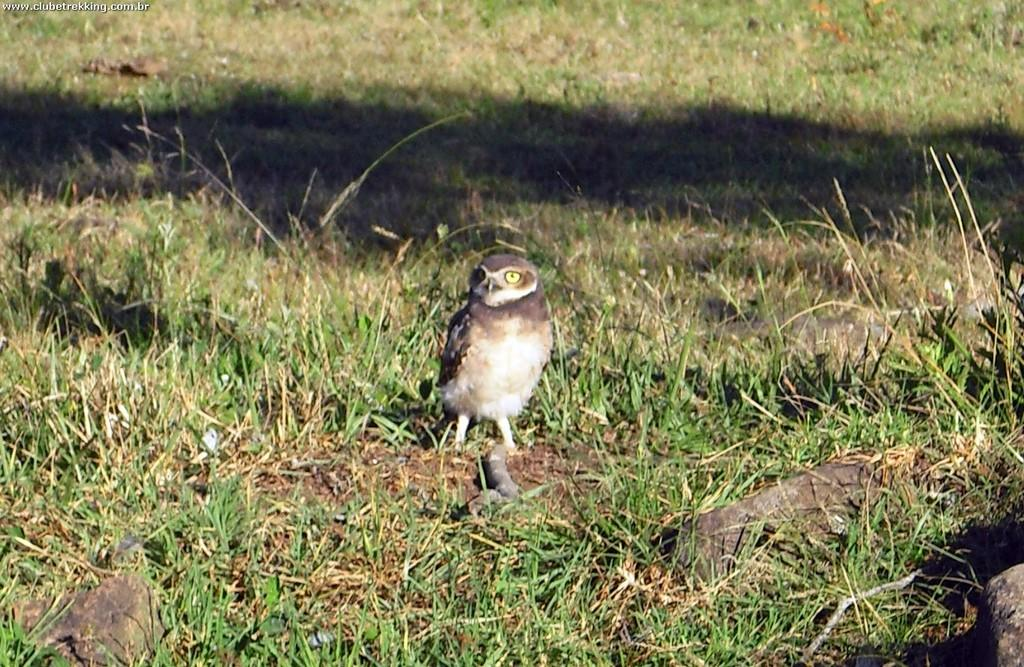Where was the image taken? The image was clicked outside. What type of vegetation can be seen in the image? There is grass in the image. What animal is present in the image? There is a bird in the middle of the image. What is the title of the book the bird is reading in the image? There is no book or reading material present in the image, as it features a bird in the grass. 